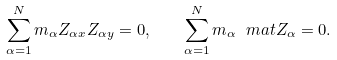<formula> <loc_0><loc_0><loc_500><loc_500>\sum _ { \alpha = 1 } ^ { N } m _ { \alpha } Z _ { \alpha x } Z _ { \alpha y } = 0 , \quad \sum _ { \alpha = 1 } ^ { N } m _ { \alpha } \ m a t { Z } _ { \alpha } = 0 .</formula> 